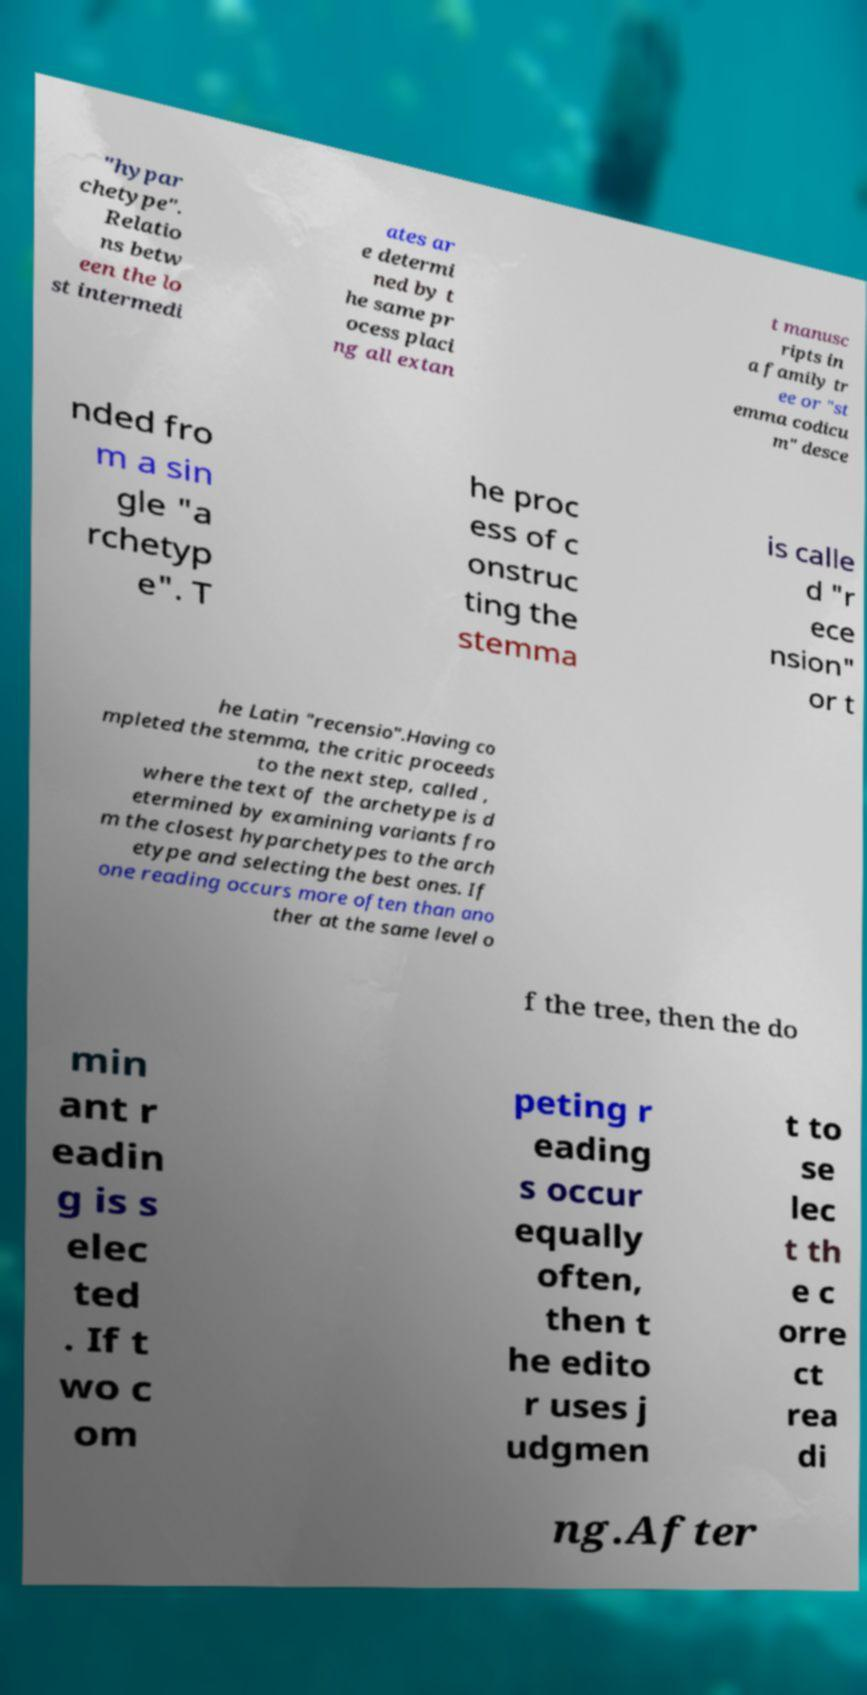Could you extract and type out the text from this image? "hypar chetype". Relatio ns betw een the lo st intermedi ates ar e determi ned by t he same pr ocess placi ng all extan t manusc ripts in a family tr ee or "st emma codicu m" desce nded fro m a sin gle "a rchetyp e". T he proc ess of c onstruc ting the stemma is calle d "r ece nsion" or t he Latin "recensio".Having co mpleted the stemma, the critic proceeds to the next step, called , where the text of the archetype is d etermined by examining variants fro m the closest hyparchetypes to the arch etype and selecting the best ones. If one reading occurs more often than ano ther at the same level o f the tree, then the do min ant r eadin g is s elec ted . If t wo c om peting r eading s occur equally often, then t he edito r uses j udgmen t to se lec t th e c orre ct rea di ng.After 